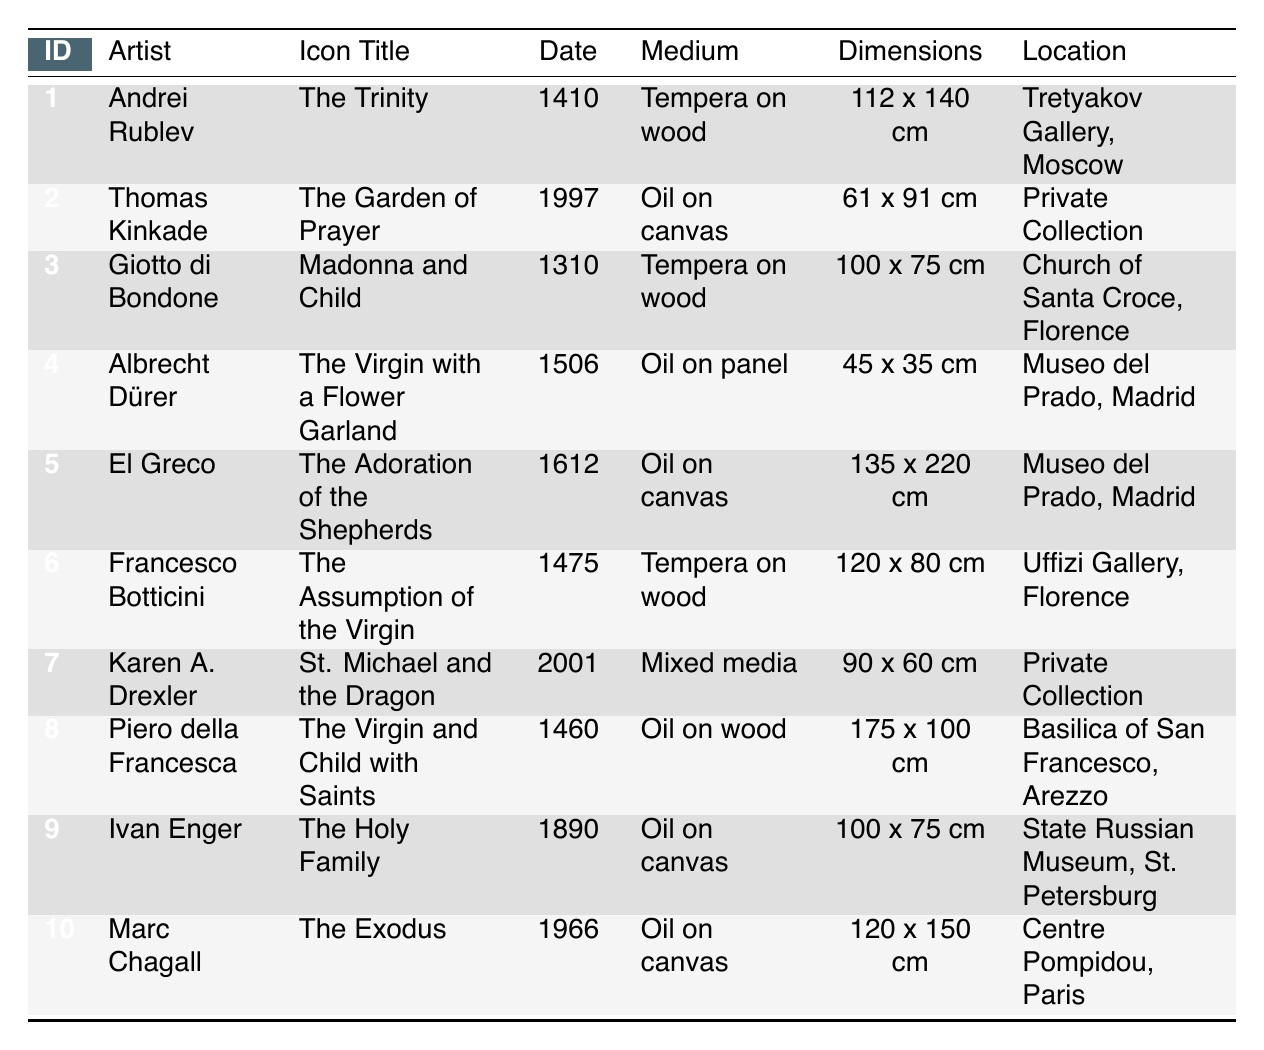What is the medium used for "The Trinity" by Andrei Rublev? The table shows the medium for each icon. Looking at the row for "The Trinity," the medium is stated as "Tempera on wood."
Answer: Tempera on wood How many icons were created in the 15th century? The table provides dates for each icon. The relevant entries for the 15th century are for "The Virgin with a Flower Garland" (1506), "The Assumption of the Virgin" (1475), and "The Virgin and Child with Saints" (1460). Counting these, there are three icons from the 15th century.
Answer: 3 Is "The Garden of Prayer" the only icon created in the 1990s? By examining the entries from the 1990s, "The Garden of Prayer" (1997) is the only one listed. There are no other icons created in the 1990s.
Answer: Yes Which artist created icons in both the 15th and the 20th centuries? The table must be reviewed for artists associated with these centuries. Albrecht Dürer has an icon (1506) from the 15th century and Karen A. Drexler has an icon (2001) from the 21st century. Thus, there is no artist who created in both the 15th and the 20th centuries.
Answer: No What is the average size of the icons created in the 20th century? First, identify the icons from the 20th century: "St. Michael and the Dragon" (90 x 60 cm) and "The Exodus" (120 x 150 cm). Calculate the average dimensions: the total areas are 5400 cm² (90 x 60) and 18000 cm² (120 x 150), for a total of 23400 cm². Divide by the number of icons (2) gives 11700 cm². On average, the width and height of the icons can also be averaged separately (90 + 120) / 2 = 105 cm and (60 + 150) / 2 = 105 cm, providing dimensions of approximately 105 x 105 cm.
Answer: 105 x 105 cm 